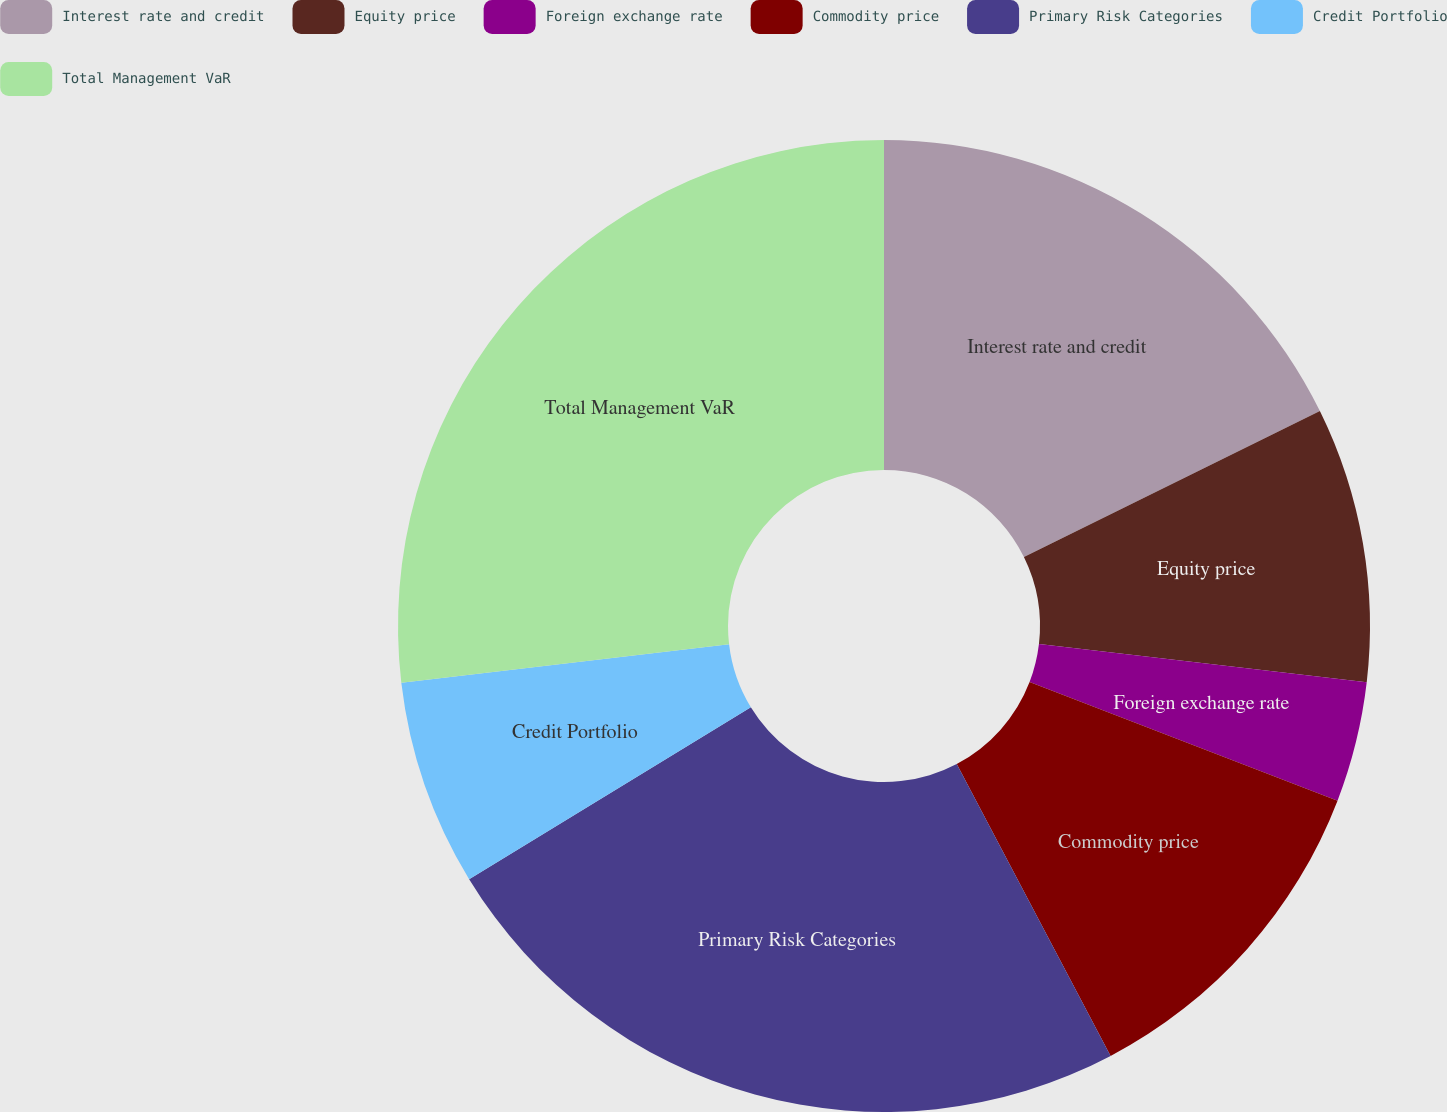<chart> <loc_0><loc_0><loc_500><loc_500><pie_chart><fcel>Interest rate and credit<fcel>Equity price<fcel>Foreign exchange rate<fcel>Commodity price<fcel>Primary Risk Categories<fcel>Credit Portfolio<fcel>Total Management VaR<nl><fcel>17.71%<fcel>9.14%<fcel>4.0%<fcel>11.43%<fcel>24.0%<fcel>6.86%<fcel>26.86%<nl></chart> 